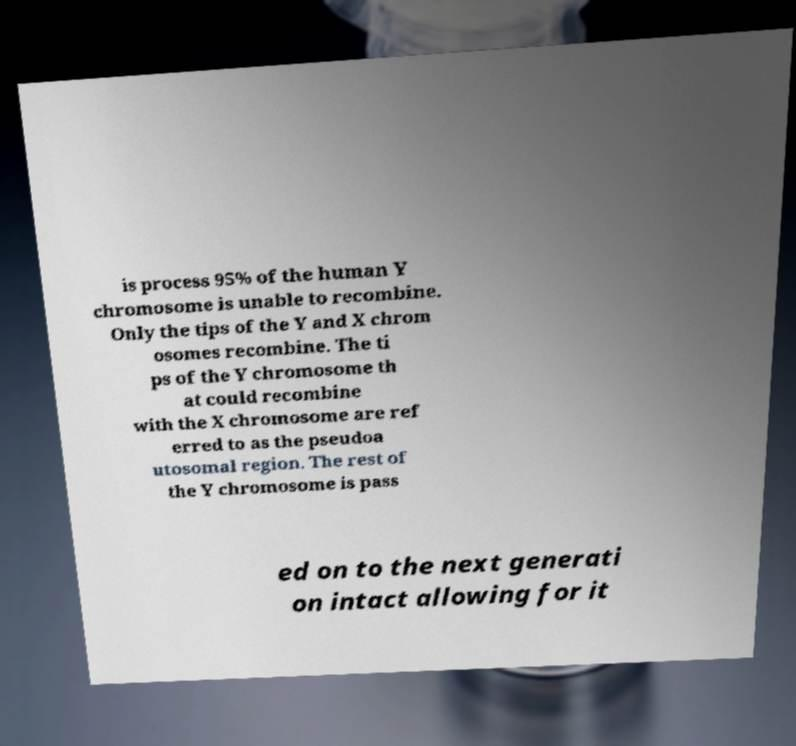Could you assist in decoding the text presented in this image and type it out clearly? is process 95% of the human Y chromosome is unable to recombine. Only the tips of the Y and X chrom osomes recombine. The ti ps of the Y chromosome th at could recombine with the X chromosome are ref erred to as the pseudoa utosomal region. The rest of the Y chromosome is pass ed on to the next generati on intact allowing for it 